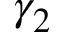<formula> <loc_0><loc_0><loc_500><loc_500>\gamma _ { 2 }</formula> 